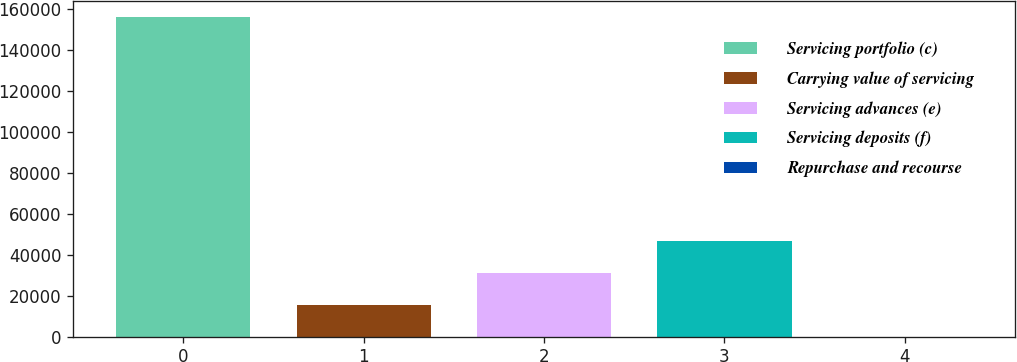Convert chart to OTSL. <chart><loc_0><loc_0><loc_500><loc_500><bar_chart><fcel>Servicing portfolio (c)<fcel>Carrying value of servicing<fcel>Servicing advances (e)<fcel>Servicing deposits (f)<fcel>Repurchase and recourse<nl><fcel>155813<fcel>15623.6<fcel>31200.2<fcel>46776.8<fcel>47<nl></chart> 